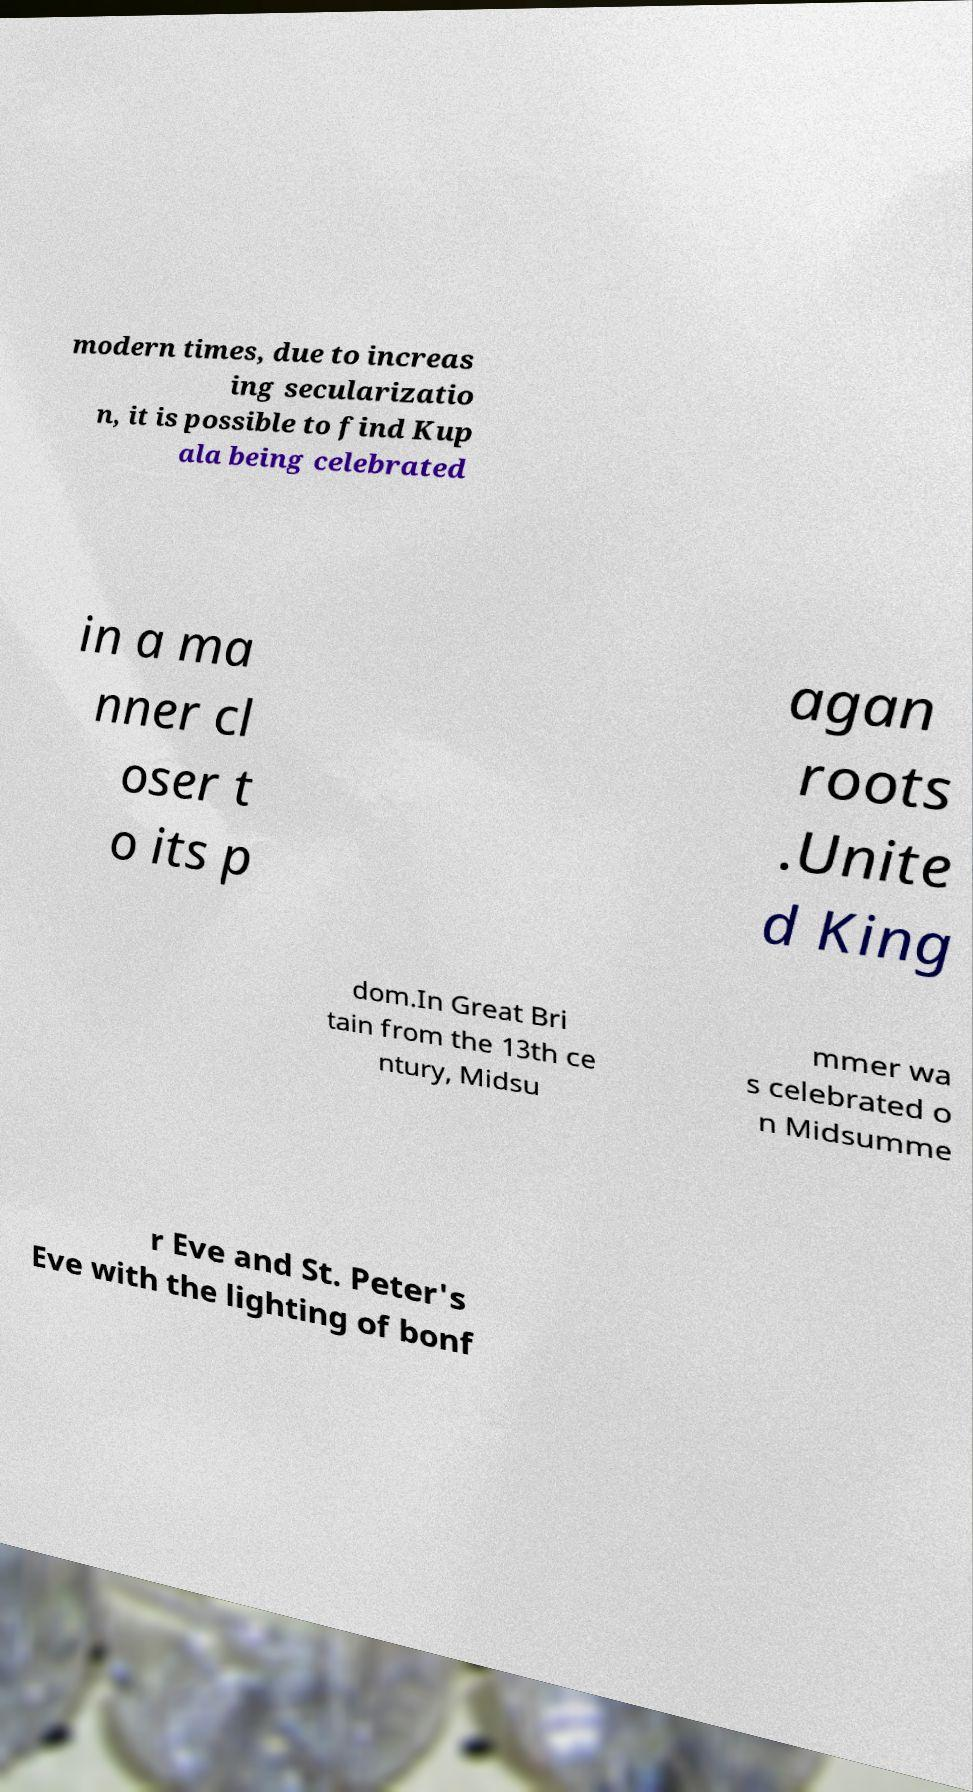There's text embedded in this image that I need extracted. Can you transcribe it verbatim? modern times, due to increas ing secularizatio n, it is possible to find Kup ala being celebrated in a ma nner cl oser t o its p agan roots .Unite d King dom.In Great Bri tain from the 13th ce ntury, Midsu mmer wa s celebrated o n Midsumme r Eve and St. Peter's Eve with the lighting of bonf 